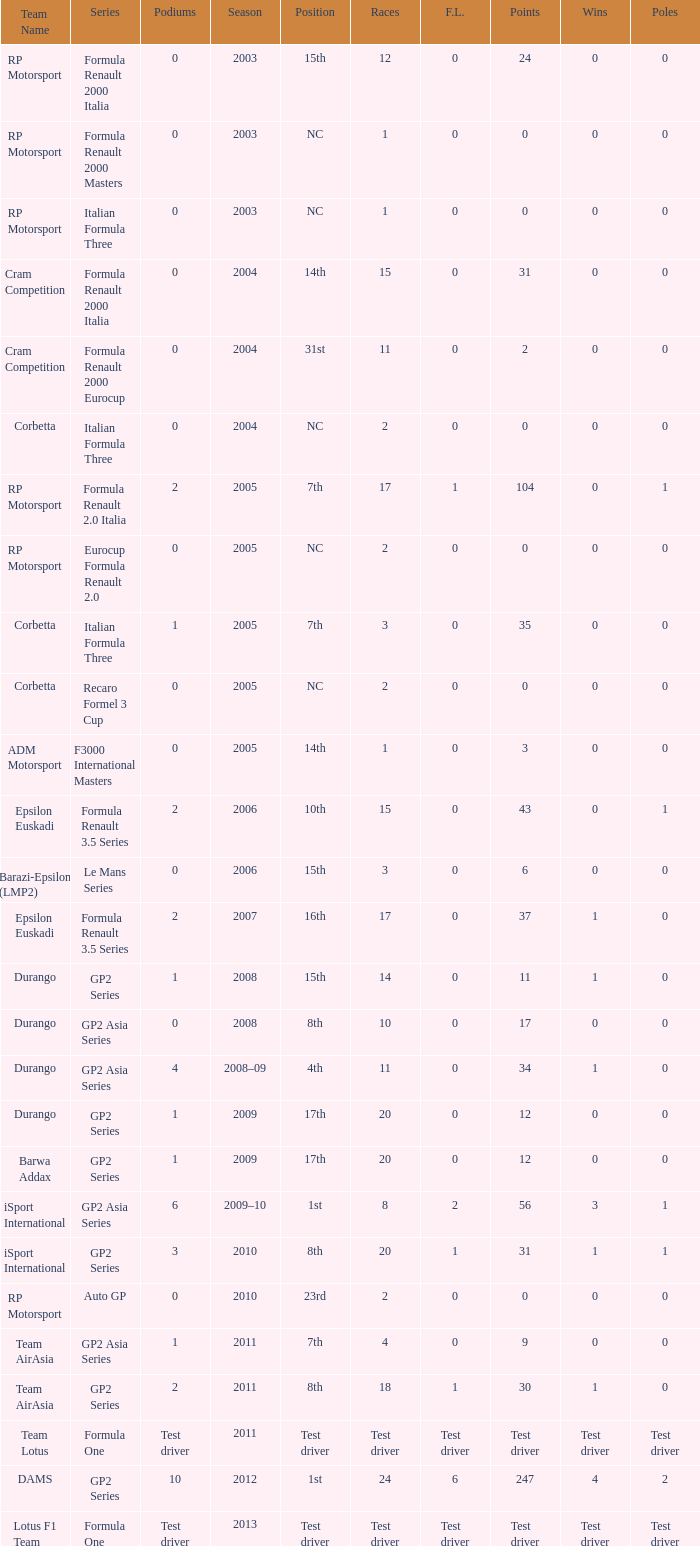What is the number of podiums with 0 wins and 6 points? 0.0. 